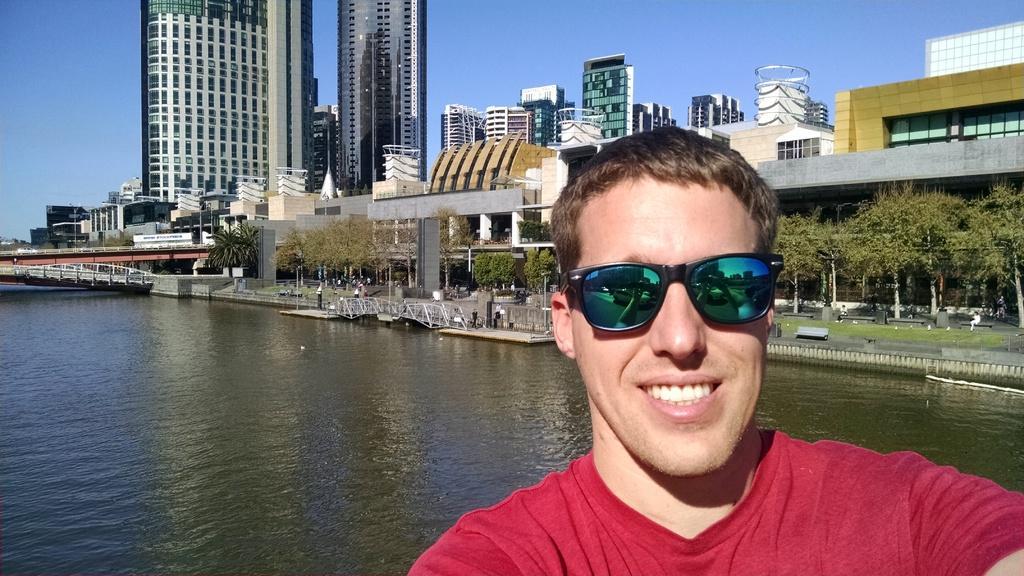How would you summarize this image in a sentence or two? In this image we can see a person wearing T-shirt and the goggles, behind him there are some buildings, trees, benches, also we can see river, bridge, poles, and the sky. 